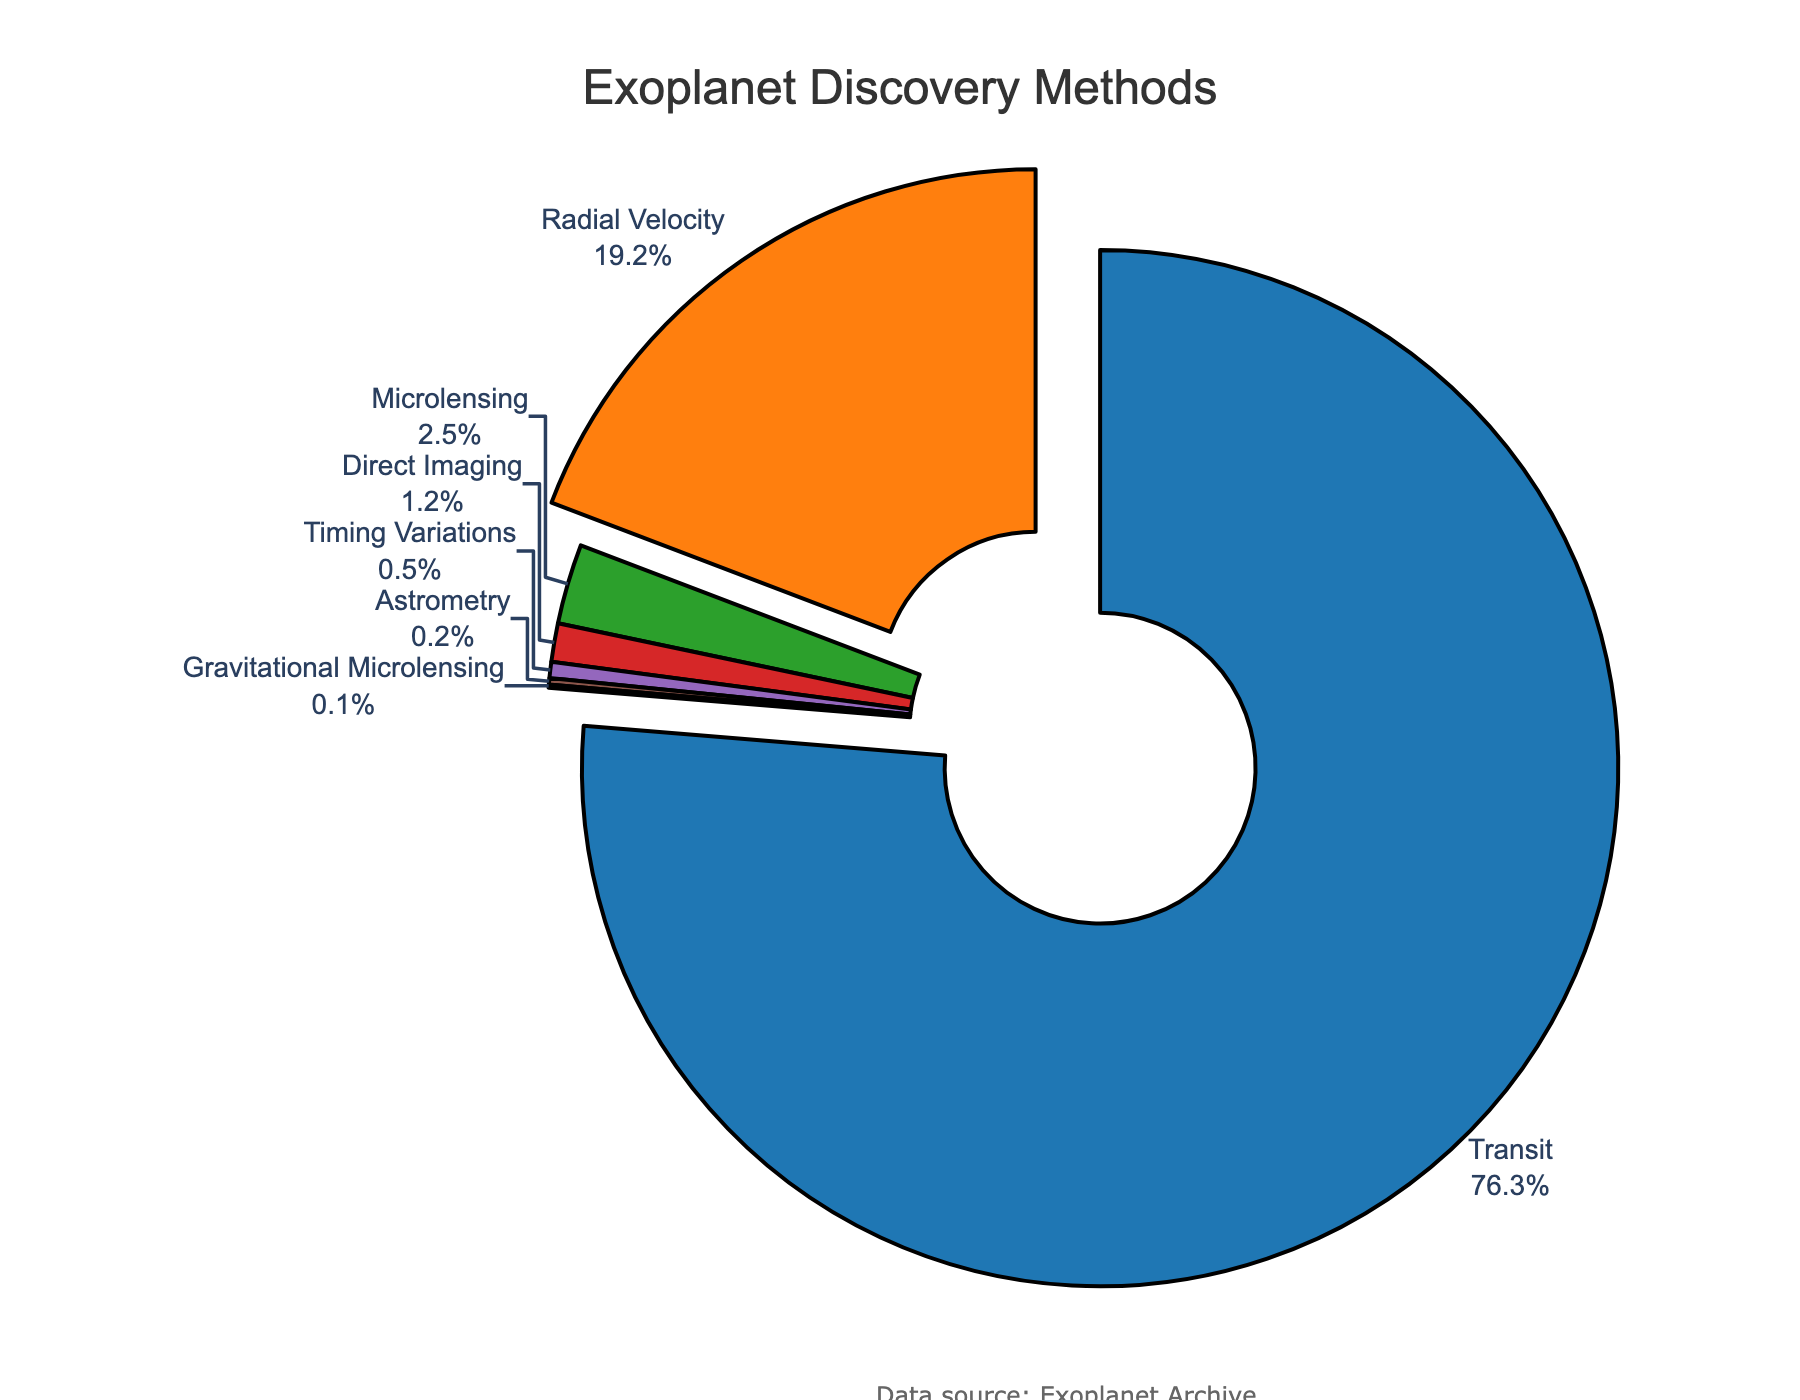What percentage of exoplanets were discovered using the two least common methods combined? The two least common methods are Astrometry and Gravitational Microlensing with percentages 0.2% and 0.1%, respectively. Adding these gives 0.2 + 0.1 = 0.3%.
Answer: 0.3% Which detection method discovered the most exoplanets? The detection method with the highest percentage is Transit, which discovered 76.3% of exoplanets.
Answer: Transit How much more common is the Transit method compared to the Direct Imaging method? Transit has a percentage of 76.3%, and Direct Imaging has 1.2%. The difference is 76.3 - 1.2 = 75.1%.
Answer: 75.1% What is the combined percentage of exoplanets discovered by Radial Velocity and Transit methods? Radial Velocity accounts for 19.2% and Transit 76.3%. Adding them gives 19.2 + 76.3 = 95.5%.
Answer: 95.5% Between Radial Velocity and Microlensing, which discovery method has a higher percentage, and by how much? Radial Velocity’s percentage is 19.2%, and Microlensing’s percentage is 2.5%. The difference is 19.2 - 2.5 = 16.7%. Radial Velocity is higher by 16.7%.
Answer: Radial Velocity by 16.7% How much less common is Timing Variations compared to Microlensing? Timing Variations has a percentage of 0.5%, and Microlensing has 2.5%. The difference is 2.5 - 0.5 = 2%.
Answer: 2% What is the average percentage of exoplanets discovered by Astrometry and Timing Variations combined? The percentages for Astrometry and Timing Variations are 0.2% and 0.5%, respectively. Adding them gives 0.2 + 0.5 = 0.7%. The average is 0.7 / 2 = 0.35%.
Answer: 0.35% What is the median detection method by percentage when all methods are considered? Listing percentages in ascending order: 0.1, 0.2, 0.5, 1.2, 2.5, 19.2, 76.3. The median value is the fourth value in this sorted list, which is 1.2%.
Answer: 1.2% What percentage of exoplanets were discovered by methods other than Transit? Transit discovered 76.3% of exoplanets. The remaining percentage is 100 - 76.3 = 23.7%.
Answer: 23.7% If we add the percentages of Direct Imaging, Timing Variations, and Gravitational Microlensing, does it exceed that of Microlensing alone? Direct Imaging 1.2%, Timing Variations 0.5%, and Gravitational Microlensing 0.1%. Adding them gives 1.2 + 0.5 + 0.1 = 1.8%, which is less than Microlensing's 2.5%.
Answer: No 